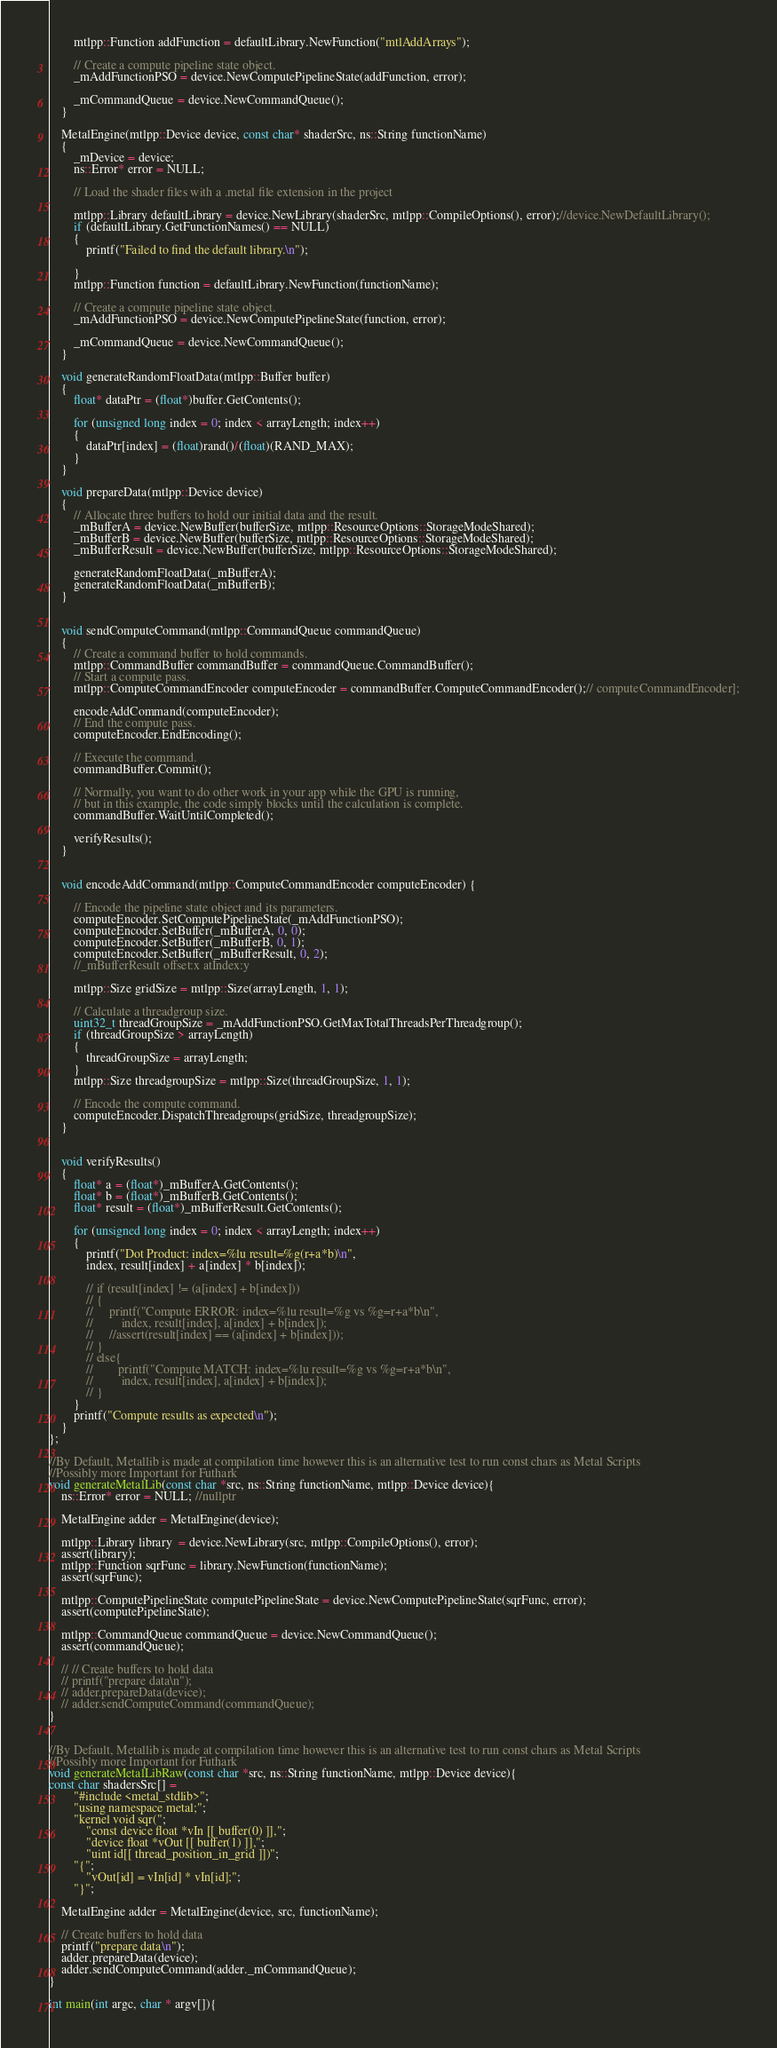<code> <loc_0><loc_0><loc_500><loc_500><_C++_>        mtlpp::Function addFunction = defaultLibrary.NewFunction("mtlAddArrays");

        // Create a compute pipeline state object.
        _mAddFunctionPSO = device.NewComputePipelineState(addFunction, error);
    
        _mCommandQueue = device.NewCommandQueue();
    }

    MetalEngine(mtlpp::Device device, const char* shaderSrc, ns::String functionName)
    {
        _mDevice = device;
        ns::Error* error = NULL;

        // Load the shader files with a .metal file extension in the project

        mtlpp::Library defaultLibrary = device.NewLibrary(shaderSrc, mtlpp::CompileOptions(), error);//device.NewDefaultLibrary();
        if (defaultLibrary.GetFunctionNames() == NULL)
        {
            printf("Failed to find the default library.\n");

        }
        mtlpp::Function function = defaultLibrary.NewFunction(functionName);

        // Create a compute pipeline state object.
        _mAddFunctionPSO = device.NewComputePipelineState(function, error);
    
        _mCommandQueue = device.NewCommandQueue();
    }

    void generateRandomFloatData(mtlpp::Buffer buffer)
    {
        float* dataPtr = (float*)buffer.GetContents();

        for (unsigned long index = 0; index < arrayLength; index++)
        {
            dataPtr[index] = (float)rand()/(float)(RAND_MAX);
        }
    }

    void prepareData(mtlpp::Device device)
    {
        // Allocate three buffers to hold our initial data and the result.
        _mBufferA = device.NewBuffer(bufferSize, mtlpp::ResourceOptions::StorageModeShared);
        _mBufferB = device.NewBuffer(bufferSize, mtlpp::ResourceOptions::StorageModeShared);
        _mBufferResult = device.NewBuffer(bufferSize, mtlpp::ResourceOptions::StorageModeShared);

        generateRandomFloatData(_mBufferA);
        generateRandomFloatData(_mBufferB);
    }


    void sendComputeCommand(mtlpp::CommandQueue commandQueue)
    {
        // Create a command buffer to hold commands.
        mtlpp::CommandBuffer commandBuffer = commandQueue.CommandBuffer();
        // Start a compute pass.
        mtlpp::ComputeCommandEncoder computeEncoder = commandBuffer.ComputeCommandEncoder();// computeCommandEncoder];

        encodeAddCommand(computeEncoder);
        // End the compute pass.
        computeEncoder.EndEncoding();

        // Execute the command.
        commandBuffer.Commit();

        // Normally, you want to do other work in your app while the GPU is running,
        // but in this example, the code simply blocks until the calculation is complete.
        commandBuffer.WaitUntilCompleted();

        verifyResults();
    }


    void encodeAddCommand(mtlpp::ComputeCommandEncoder computeEncoder) {

        // Encode the pipeline state object and its parameters.
        computeEncoder.SetComputePipelineState(_mAddFunctionPSO);
        computeEncoder.SetBuffer(_mBufferA, 0, 0);
        computeEncoder.SetBuffer(_mBufferB, 0, 1);
        computeEncoder.SetBuffer(_mBufferResult, 0, 2);
        //_mBufferResult offset:x atIndex:y

        mtlpp::Size gridSize = mtlpp::Size(arrayLength, 1, 1);

        // Calculate a threadgroup size.
        uint32_t threadGroupSize = _mAddFunctionPSO.GetMaxTotalThreadsPerThreadgroup();
        if (threadGroupSize > arrayLength)
        {
            threadGroupSize = arrayLength;
        }
        mtlpp::Size threadgroupSize = mtlpp::Size(threadGroupSize, 1, 1);

        // Encode the compute command.
        computeEncoder.DispatchThreadgroups(gridSize, threadgroupSize);
    }


    void verifyResults()
    {
        float* a = (float*)_mBufferA.GetContents();
        float* b = (float*)_mBufferB.GetContents();
        float* result = (float*)_mBufferResult.GetContents();

        for (unsigned long index = 0; index < arrayLength; index++)
        {
            printf("Dot Product: index=%lu result=%g(r+a*b)\n",
            index, result[index] + a[index] * b[index]);

            // if (result[index] != (a[index] + b[index]))
            // {
            //     printf("Compute ERROR: index=%lu result=%g vs %g=r+a*b\n",
            //         index, result[index], a[index] + b[index]);
            //     //assert(result[index] == (a[index] + b[index]));
            // }
            // else{
            //        printf("Compute MATCH: index=%lu result=%g vs %g=r+a*b\n",
            //         index, result[index], a[index] + b[index]);
            // }
        }
        printf("Compute results as expected\n");
    }
};

//By Default, Metallib is made at compilation time however this is an alternative test to run const chars as Metal Scripts
//Possibly more Important for Futhark
void generateMetalLib(const char *src, ns::String functionName, mtlpp::Device device){
    ns::Error* error = NULL; //nullptr
    
    MetalEngine adder = MetalEngine(device);

    mtlpp::Library library  = device.NewLibrary(src, mtlpp::CompileOptions(), error);
    assert(library);
    mtlpp::Function sqrFunc = library.NewFunction(functionName);
    assert(sqrFunc);

    mtlpp::ComputePipelineState computePipelineState = device.NewComputePipelineState(sqrFunc, error);
    assert(computePipelineState);

    mtlpp::CommandQueue commandQueue = device.NewCommandQueue();
    assert(commandQueue);

    // // Create buffers to hold data
    // printf("prepare data\n");
    // adder.prepareData(device);
    // adder.sendComputeCommand(commandQueue);
}


//By Default, Metallib is made at compilation time however this is an alternative test to run const chars as Metal Scripts
//Possibly more Important for Futhark
void generateMetalLibRaw(const char *src, ns::String functionName, mtlpp::Device device){
const char shadersSrc[] = 
        "#include <metal_stdlib>";
        "using namespace metal;";
        "kernel void sqr(";
            "const device float *vIn [[ buffer(0) ]],";
            "device float *vOut [[ buffer(1) ]],";
            "uint id[[ thread_position_in_grid ]])";
        "{";
            "vOut[id] = vIn[id] * vIn[id];";       
        "}";
    
    MetalEngine adder = MetalEngine(device, src, functionName);

    // Create buffers to hold data
    printf("prepare data\n");
    adder.prepareData(device);
    adder.sendComputeCommand(adder._mCommandQueue);
}

int main(int argc, char * argv[]){</code> 